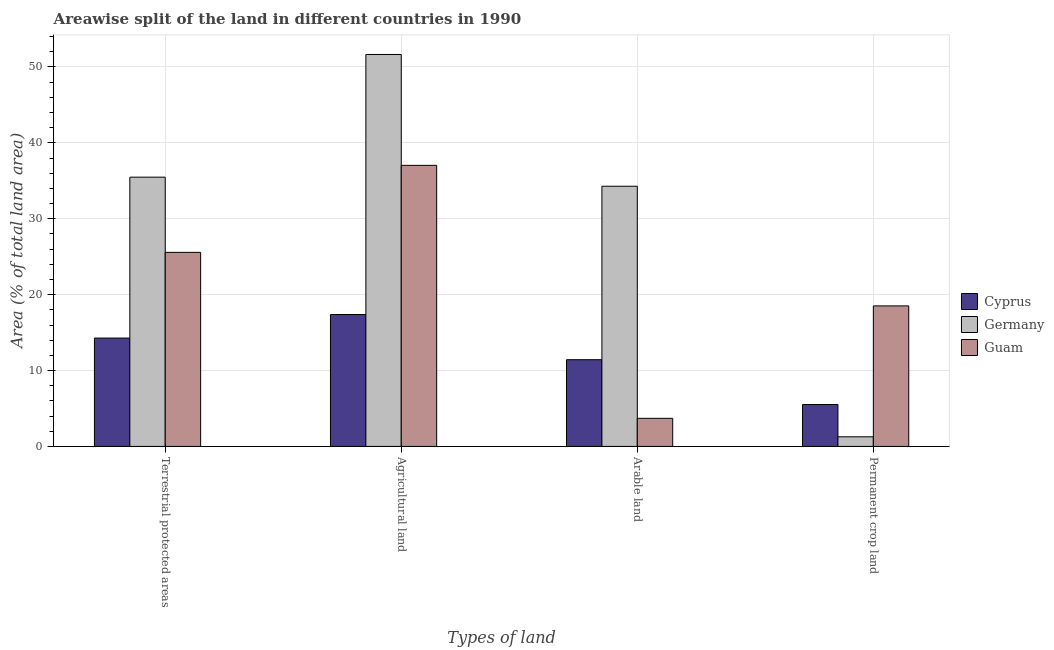How many groups of bars are there?
Offer a terse response. 4. Are the number of bars per tick equal to the number of legend labels?
Your answer should be very brief. Yes. Are the number of bars on each tick of the X-axis equal?
Ensure brevity in your answer.  Yes. What is the label of the 4th group of bars from the left?
Provide a succinct answer. Permanent crop land. What is the percentage of area under permanent crop land in Guam?
Provide a short and direct response. 18.52. Across all countries, what is the maximum percentage of land under terrestrial protection?
Give a very brief answer. 35.48. Across all countries, what is the minimum percentage of area under arable land?
Your answer should be compact. 3.7. In which country was the percentage of area under agricultural land minimum?
Give a very brief answer. Cyprus. What is the total percentage of area under permanent crop land in the graph?
Your response must be concise. 25.31. What is the difference between the percentage of area under permanent crop land in Guam and that in Cyprus?
Provide a short and direct response. 13. What is the difference between the percentage of area under permanent crop land in Cyprus and the percentage of area under agricultural land in Guam?
Ensure brevity in your answer.  -31.52. What is the average percentage of land under terrestrial protection per country?
Your response must be concise. 25.11. What is the difference between the percentage of area under arable land and percentage of area under agricultural land in Germany?
Provide a short and direct response. -17.36. In how many countries, is the percentage of area under permanent crop land greater than 8 %?
Provide a short and direct response. 1. What is the ratio of the percentage of area under agricultural land in Guam to that in Cyprus?
Ensure brevity in your answer.  2.13. Is the percentage of area under agricultural land in Guam less than that in Cyprus?
Offer a very short reply. No. What is the difference between the highest and the second highest percentage of area under arable land?
Offer a very short reply. 22.86. What is the difference between the highest and the lowest percentage of area under arable land?
Ensure brevity in your answer.  30.58. In how many countries, is the percentage of area under agricultural land greater than the average percentage of area under agricultural land taken over all countries?
Your answer should be very brief. 2. Is the sum of the percentage of area under agricultural land in Cyprus and Guam greater than the maximum percentage of land under terrestrial protection across all countries?
Ensure brevity in your answer.  Yes. Is it the case that in every country, the sum of the percentage of area under permanent crop land and percentage of land under terrestrial protection is greater than the sum of percentage of area under agricultural land and percentage of area under arable land?
Make the answer very short. No. What does the 3rd bar from the left in Permanent crop land represents?
Offer a terse response. Guam. What does the 3rd bar from the right in Terrestrial protected areas represents?
Provide a short and direct response. Cyprus. Is it the case that in every country, the sum of the percentage of land under terrestrial protection and percentage of area under agricultural land is greater than the percentage of area under arable land?
Offer a very short reply. Yes. How many countries are there in the graph?
Provide a succinct answer. 3. Are the values on the major ticks of Y-axis written in scientific E-notation?
Offer a very short reply. No. How many legend labels are there?
Ensure brevity in your answer.  3. How are the legend labels stacked?
Provide a succinct answer. Vertical. What is the title of the graph?
Ensure brevity in your answer.  Areawise split of the land in different countries in 1990. What is the label or title of the X-axis?
Provide a short and direct response. Types of land. What is the label or title of the Y-axis?
Offer a very short reply. Area (% of total land area). What is the Area (% of total land area) in Cyprus in Terrestrial protected areas?
Keep it short and to the point. 14.28. What is the Area (% of total land area) of Germany in Terrestrial protected areas?
Offer a very short reply. 35.48. What is the Area (% of total land area) of Guam in Terrestrial protected areas?
Provide a succinct answer. 25.57. What is the Area (% of total land area) of Cyprus in Agricultural land?
Your answer should be compact. 17.38. What is the Area (% of total land area) of Germany in Agricultural land?
Provide a succinct answer. 51.65. What is the Area (% of total land area) of Guam in Agricultural land?
Offer a very short reply. 37.04. What is the Area (% of total land area) of Cyprus in Arable land?
Your answer should be very brief. 11.43. What is the Area (% of total land area) in Germany in Arable land?
Make the answer very short. 34.29. What is the Area (% of total land area) in Guam in Arable land?
Keep it short and to the point. 3.7. What is the Area (% of total land area) in Cyprus in Permanent crop land?
Make the answer very short. 5.52. What is the Area (% of total land area) of Germany in Permanent crop land?
Offer a terse response. 1.27. What is the Area (% of total land area) of Guam in Permanent crop land?
Keep it short and to the point. 18.52. Across all Types of land, what is the maximum Area (% of total land area) of Cyprus?
Provide a short and direct response. 17.38. Across all Types of land, what is the maximum Area (% of total land area) in Germany?
Keep it short and to the point. 51.65. Across all Types of land, what is the maximum Area (% of total land area) of Guam?
Provide a short and direct response. 37.04. Across all Types of land, what is the minimum Area (% of total land area) in Cyprus?
Give a very brief answer. 5.52. Across all Types of land, what is the minimum Area (% of total land area) in Germany?
Provide a short and direct response. 1.27. Across all Types of land, what is the minimum Area (% of total land area) in Guam?
Provide a succinct answer. 3.7. What is the total Area (% of total land area) of Cyprus in the graph?
Make the answer very short. 48.61. What is the total Area (% of total land area) of Germany in the graph?
Provide a succinct answer. 122.69. What is the total Area (% of total land area) of Guam in the graph?
Give a very brief answer. 84.83. What is the difference between the Area (% of total land area) in Cyprus in Terrestrial protected areas and that in Agricultural land?
Your response must be concise. -3.1. What is the difference between the Area (% of total land area) in Germany in Terrestrial protected areas and that in Agricultural land?
Offer a very short reply. -16.17. What is the difference between the Area (% of total land area) of Guam in Terrestrial protected areas and that in Agricultural land?
Your answer should be compact. -11.46. What is the difference between the Area (% of total land area) in Cyprus in Terrestrial protected areas and that in Arable land?
Provide a succinct answer. 2.85. What is the difference between the Area (% of total land area) of Germany in Terrestrial protected areas and that in Arable land?
Your answer should be compact. 1.19. What is the difference between the Area (% of total land area) in Guam in Terrestrial protected areas and that in Arable land?
Provide a short and direct response. 21.87. What is the difference between the Area (% of total land area) in Cyprus in Terrestrial protected areas and that in Permanent crop land?
Your answer should be very brief. 8.76. What is the difference between the Area (% of total land area) of Germany in Terrestrial protected areas and that in Permanent crop land?
Provide a short and direct response. 34.21. What is the difference between the Area (% of total land area) of Guam in Terrestrial protected areas and that in Permanent crop land?
Offer a terse response. 7.06. What is the difference between the Area (% of total land area) in Cyprus in Agricultural land and that in Arable land?
Keep it short and to the point. 5.95. What is the difference between the Area (% of total land area) of Germany in Agricultural land and that in Arable land?
Your response must be concise. 17.36. What is the difference between the Area (% of total land area) in Guam in Agricultural land and that in Arable land?
Provide a short and direct response. 33.33. What is the difference between the Area (% of total land area) in Cyprus in Agricultural land and that in Permanent crop land?
Give a very brief answer. 11.86. What is the difference between the Area (% of total land area) of Germany in Agricultural land and that in Permanent crop land?
Your answer should be very brief. 50.38. What is the difference between the Area (% of total land area) of Guam in Agricultural land and that in Permanent crop land?
Your answer should be very brief. 18.52. What is the difference between the Area (% of total land area) of Cyprus in Arable land and that in Permanent crop land?
Provide a short and direct response. 5.91. What is the difference between the Area (% of total land area) in Germany in Arable land and that in Permanent crop land?
Your answer should be compact. 33.02. What is the difference between the Area (% of total land area) of Guam in Arable land and that in Permanent crop land?
Ensure brevity in your answer.  -14.81. What is the difference between the Area (% of total land area) in Cyprus in Terrestrial protected areas and the Area (% of total land area) in Germany in Agricultural land?
Offer a very short reply. -37.37. What is the difference between the Area (% of total land area) of Cyprus in Terrestrial protected areas and the Area (% of total land area) of Guam in Agricultural land?
Make the answer very short. -22.76. What is the difference between the Area (% of total land area) of Germany in Terrestrial protected areas and the Area (% of total land area) of Guam in Agricultural land?
Offer a terse response. -1.56. What is the difference between the Area (% of total land area) in Cyprus in Terrestrial protected areas and the Area (% of total land area) in Germany in Arable land?
Your answer should be compact. -20.01. What is the difference between the Area (% of total land area) of Cyprus in Terrestrial protected areas and the Area (% of total land area) of Guam in Arable land?
Give a very brief answer. 10.58. What is the difference between the Area (% of total land area) in Germany in Terrestrial protected areas and the Area (% of total land area) in Guam in Arable land?
Offer a terse response. 31.78. What is the difference between the Area (% of total land area) in Cyprus in Terrestrial protected areas and the Area (% of total land area) in Germany in Permanent crop land?
Ensure brevity in your answer.  13.01. What is the difference between the Area (% of total land area) in Cyprus in Terrestrial protected areas and the Area (% of total land area) in Guam in Permanent crop land?
Give a very brief answer. -4.24. What is the difference between the Area (% of total land area) of Germany in Terrestrial protected areas and the Area (% of total land area) of Guam in Permanent crop land?
Provide a short and direct response. 16.96. What is the difference between the Area (% of total land area) in Cyprus in Agricultural land and the Area (% of total land area) in Germany in Arable land?
Your response must be concise. -16.91. What is the difference between the Area (% of total land area) of Cyprus in Agricultural land and the Area (% of total land area) of Guam in Arable land?
Keep it short and to the point. 13.68. What is the difference between the Area (% of total land area) in Germany in Agricultural land and the Area (% of total land area) in Guam in Arable land?
Your answer should be compact. 47.94. What is the difference between the Area (% of total land area) of Cyprus in Agricultural land and the Area (% of total land area) of Germany in Permanent crop land?
Provide a short and direct response. 16.11. What is the difference between the Area (% of total land area) of Cyprus in Agricultural land and the Area (% of total land area) of Guam in Permanent crop land?
Offer a very short reply. -1.14. What is the difference between the Area (% of total land area) in Germany in Agricultural land and the Area (% of total land area) in Guam in Permanent crop land?
Provide a short and direct response. 33.13. What is the difference between the Area (% of total land area) in Cyprus in Arable land and the Area (% of total land area) in Germany in Permanent crop land?
Give a very brief answer. 10.16. What is the difference between the Area (% of total land area) in Cyprus in Arable land and the Area (% of total land area) in Guam in Permanent crop land?
Provide a succinct answer. -7.09. What is the difference between the Area (% of total land area) of Germany in Arable land and the Area (% of total land area) of Guam in Permanent crop land?
Provide a succinct answer. 15.77. What is the average Area (% of total land area) of Cyprus per Types of land?
Your answer should be compact. 12.15. What is the average Area (% of total land area) of Germany per Types of land?
Your response must be concise. 30.67. What is the average Area (% of total land area) of Guam per Types of land?
Your answer should be very brief. 21.21. What is the difference between the Area (% of total land area) of Cyprus and Area (% of total land area) of Germany in Terrestrial protected areas?
Provide a succinct answer. -21.2. What is the difference between the Area (% of total land area) in Cyprus and Area (% of total land area) in Guam in Terrestrial protected areas?
Offer a very short reply. -11.29. What is the difference between the Area (% of total land area) of Germany and Area (% of total land area) of Guam in Terrestrial protected areas?
Provide a succinct answer. 9.91. What is the difference between the Area (% of total land area) in Cyprus and Area (% of total land area) in Germany in Agricultural land?
Your response must be concise. -34.27. What is the difference between the Area (% of total land area) in Cyprus and Area (% of total land area) in Guam in Agricultural land?
Provide a succinct answer. -19.66. What is the difference between the Area (% of total land area) of Germany and Area (% of total land area) of Guam in Agricultural land?
Provide a short and direct response. 14.61. What is the difference between the Area (% of total land area) in Cyprus and Area (% of total land area) in Germany in Arable land?
Your answer should be very brief. -22.86. What is the difference between the Area (% of total land area) in Cyprus and Area (% of total land area) in Guam in Arable land?
Your answer should be compact. 7.72. What is the difference between the Area (% of total land area) of Germany and Area (% of total land area) of Guam in Arable land?
Your answer should be very brief. 30.58. What is the difference between the Area (% of total land area) in Cyprus and Area (% of total land area) in Germany in Permanent crop land?
Your answer should be very brief. 4.25. What is the difference between the Area (% of total land area) of Cyprus and Area (% of total land area) of Guam in Permanent crop land?
Give a very brief answer. -13. What is the difference between the Area (% of total land area) of Germany and Area (% of total land area) of Guam in Permanent crop land?
Make the answer very short. -17.25. What is the ratio of the Area (% of total land area) in Cyprus in Terrestrial protected areas to that in Agricultural land?
Keep it short and to the point. 0.82. What is the ratio of the Area (% of total land area) in Germany in Terrestrial protected areas to that in Agricultural land?
Give a very brief answer. 0.69. What is the ratio of the Area (% of total land area) of Guam in Terrestrial protected areas to that in Agricultural land?
Your response must be concise. 0.69. What is the ratio of the Area (% of total land area) in Cyprus in Terrestrial protected areas to that in Arable land?
Ensure brevity in your answer.  1.25. What is the ratio of the Area (% of total land area) in Germany in Terrestrial protected areas to that in Arable land?
Provide a succinct answer. 1.03. What is the ratio of the Area (% of total land area) in Guam in Terrestrial protected areas to that in Arable land?
Provide a short and direct response. 6.91. What is the ratio of the Area (% of total land area) in Cyprus in Terrestrial protected areas to that in Permanent crop land?
Ensure brevity in your answer.  2.59. What is the ratio of the Area (% of total land area) of Germany in Terrestrial protected areas to that in Permanent crop land?
Your answer should be very brief. 27.96. What is the ratio of the Area (% of total land area) in Guam in Terrestrial protected areas to that in Permanent crop land?
Your answer should be compact. 1.38. What is the ratio of the Area (% of total land area) in Cyprus in Agricultural land to that in Arable land?
Ensure brevity in your answer.  1.52. What is the ratio of the Area (% of total land area) of Germany in Agricultural land to that in Arable land?
Make the answer very short. 1.51. What is the ratio of the Area (% of total land area) of Cyprus in Agricultural land to that in Permanent crop land?
Ensure brevity in your answer.  3.15. What is the ratio of the Area (% of total land area) of Germany in Agricultural land to that in Permanent crop land?
Your answer should be compact. 40.7. What is the ratio of the Area (% of total land area) of Cyprus in Arable land to that in Permanent crop land?
Provide a short and direct response. 2.07. What is the ratio of the Area (% of total land area) of Germany in Arable land to that in Permanent crop land?
Ensure brevity in your answer.  27.02. What is the difference between the highest and the second highest Area (% of total land area) of Cyprus?
Offer a very short reply. 3.1. What is the difference between the highest and the second highest Area (% of total land area) of Germany?
Provide a short and direct response. 16.17. What is the difference between the highest and the second highest Area (% of total land area) of Guam?
Your answer should be compact. 11.46. What is the difference between the highest and the lowest Area (% of total land area) in Cyprus?
Provide a succinct answer. 11.86. What is the difference between the highest and the lowest Area (% of total land area) of Germany?
Keep it short and to the point. 50.38. What is the difference between the highest and the lowest Area (% of total land area) of Guam?
Ensure brevity in your answer.  33.33. 